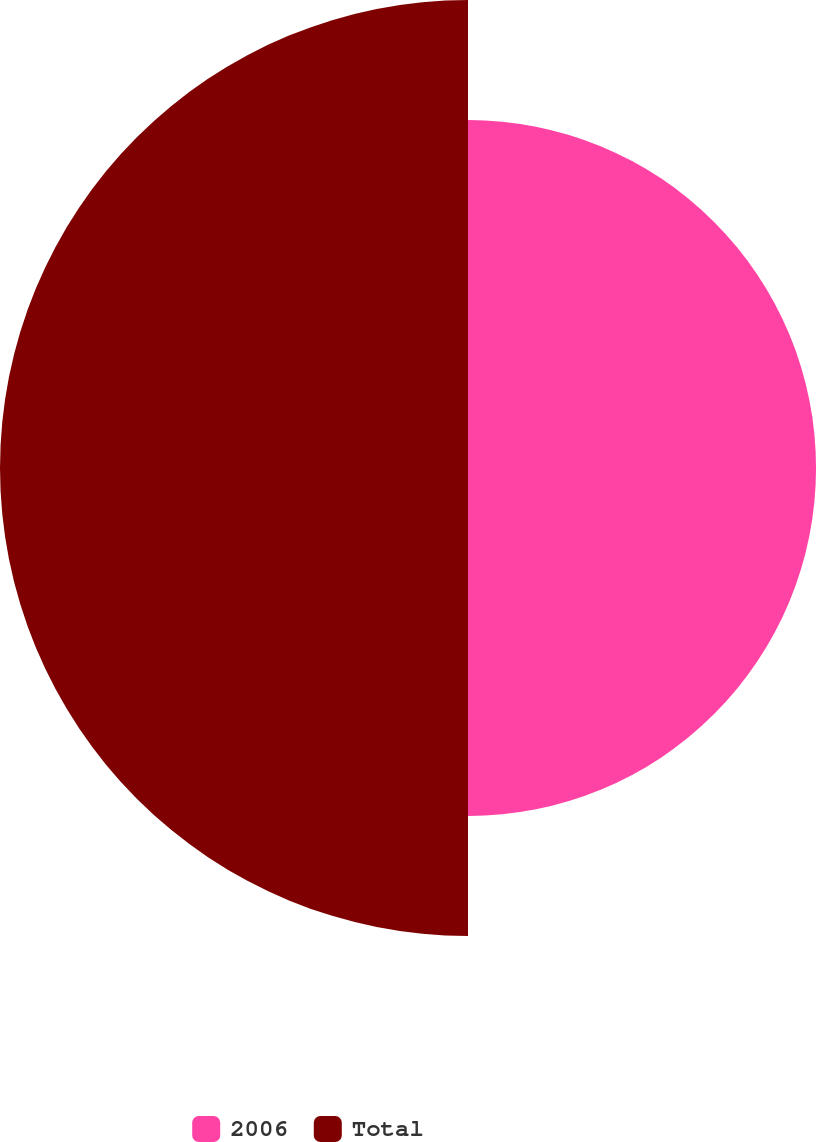<chart> <loc_0><loc_0><loc_500><loc_500><pie_chart><fcel>2006<fcel>Total<nl><fcel>42.65%<fcel>57.35%<nl></chart> 